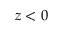<formula> <loc_0><loc_0><loc_500><loc_500>z < 0</formula> 